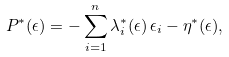Convert formula to latex. <formula><loc_0><loc_0><loc_500><loc_500>P ^ { * } ( \epsilon ) = - \sum _ { i = 1 } ^ { n } \lambda _ { i } ^ { * } ( \epsilon ) \, \epsilon _ { i } - \eta ^ { * } ( \epsilon ) ,</formula> 